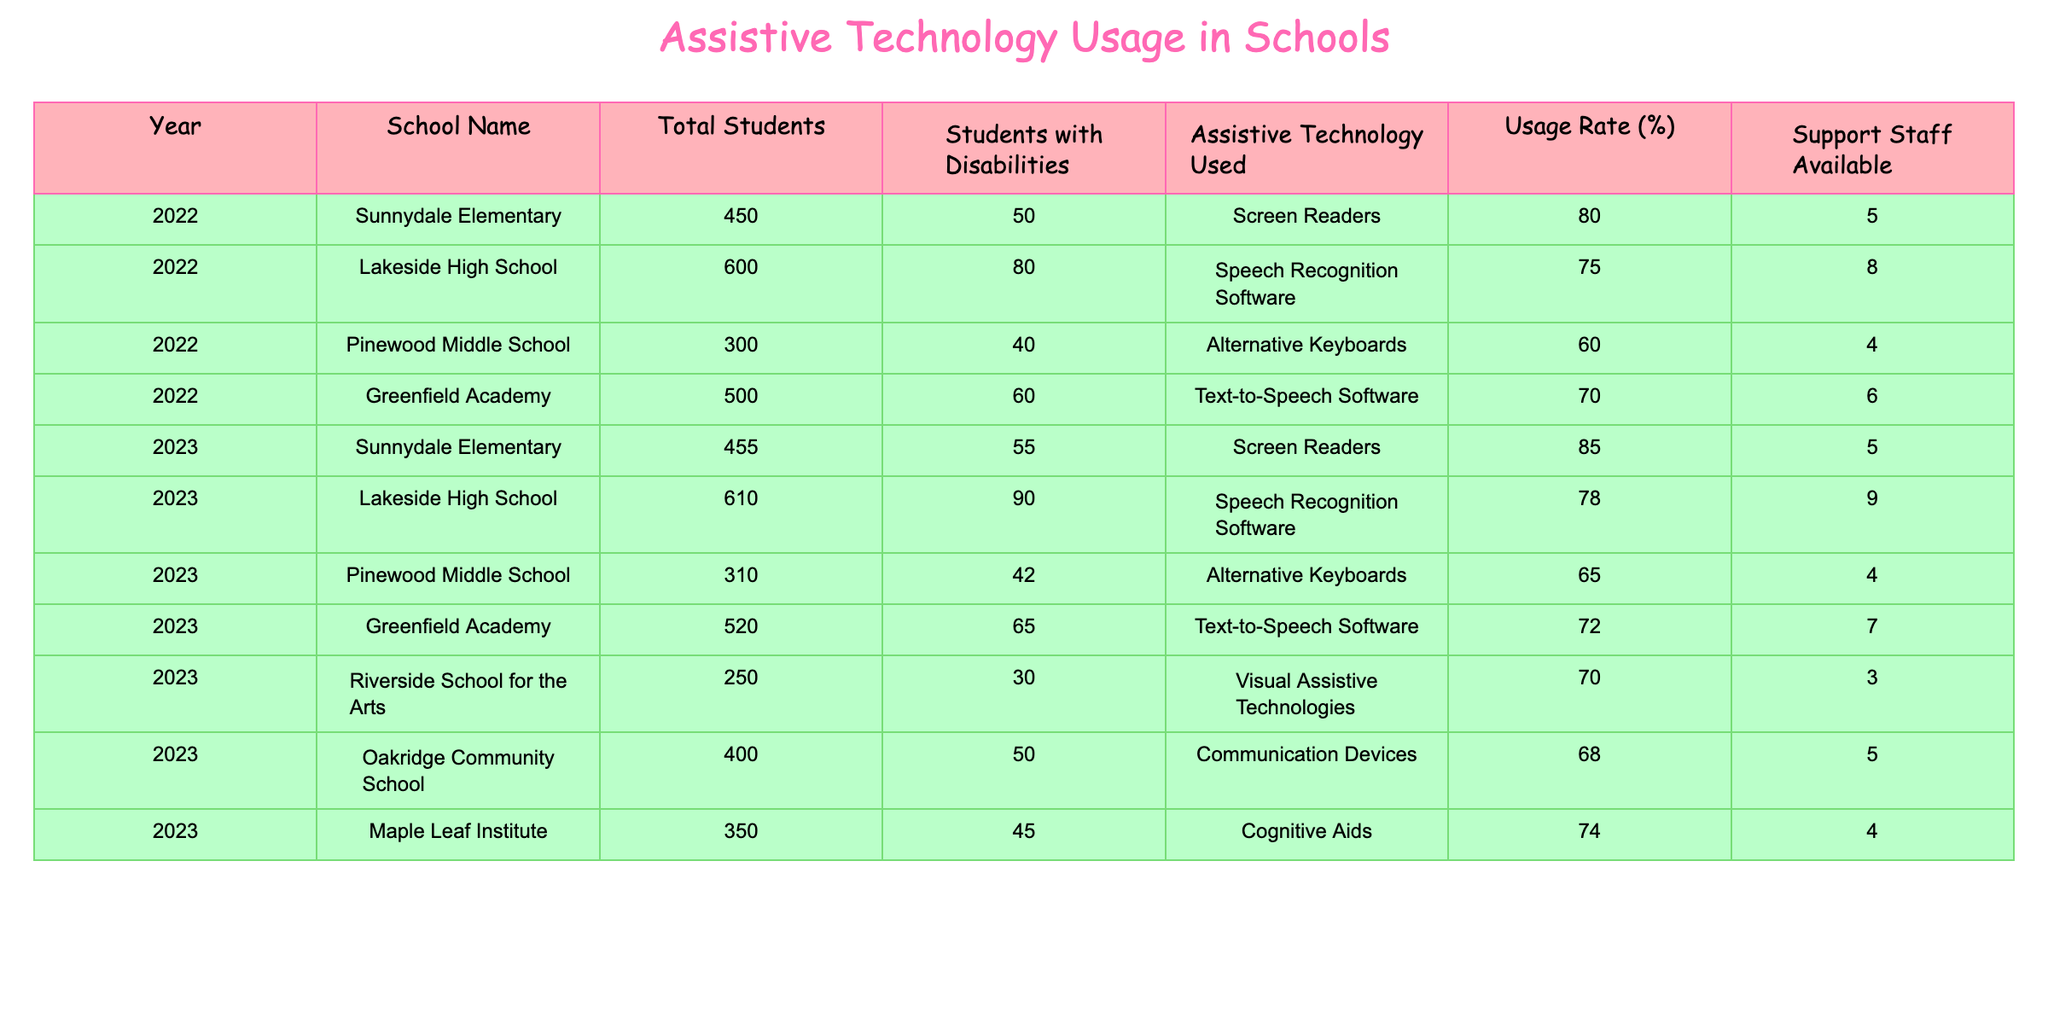What is the total number of students at Lakeside High School in 2023? By looking at the table, we can see that the total number of students at Lakeside High School for the year 2023 is listed as 610.
Answer: 610 What assistive technology is used at Greenfield Academy in 2022? The table shows that the assistive technology used at Greenfield Academy in 2022 is Text-to-Speech Software.
Answer: Text-to-Speech Software How many students with disabilities are there at Sunnydale Elementary in 2023? Referring to the table, the number of students with disabilities at Sunnydale Elementary in 2023 is 55.
Answer: 55 What is the usage rate of assistive technology at Pinewood Middle School in 2022? The table indicates that the usage rate of assistive technology at Pinewood Middle School in 2022 is 60%.
Answer: 60% Which school had the highest assistive technology usage rate in 2023? The table shows that Sunnydale Elementary had the highest usage rate at 85% in 2023.
Answer: Sunnydale Elementary What is the average number of students with disabilities across all schools in 2022? In 2022, the total number of students with disabilities across all schools is 50 (Sunnydale) + 80 (Lakeside) + 40 (Pinewood) + 60 (Greenfield) = 230. There are 4 schools, so the average is 230 / 4 = 57.5.
Answer: 57.5 Did Pinewood Middle School have a higher usage rate of assistive technology in 2022 than in 2023? In 2022 Pinewood's usage was 60% and in 2023 it was 65%, so it did not have a higher rate in 2022 than in 2023. This statement is false.
Answer: No What is the total number of students with disabilities in all schools combined for the year 2023? Adding the number of students with disabilities from each school in 2023: 55 (Sunnydale) + 90 (Lakeside) + 42 (Pinewood) + 65 (Greenfield) + 30 (Riverside) + 50 (Oakridge) + 45 (Maple Leaf) = 377.
Answer: 377 Which school has the lowest number of support staff in 2022? In 2022, Pinewood Middle School had the lowest number of support staff, which is 4.
Answer: Pinewood Middle School What is the difference in usage rate of assistive technology between Lakeside High School in 2022 and 2023? The usage rate for Lakeside High School in 2022 is 75%, and in 2023 it is 78%. The difference is 78% - 75% = 3%.
Answer: 3% 